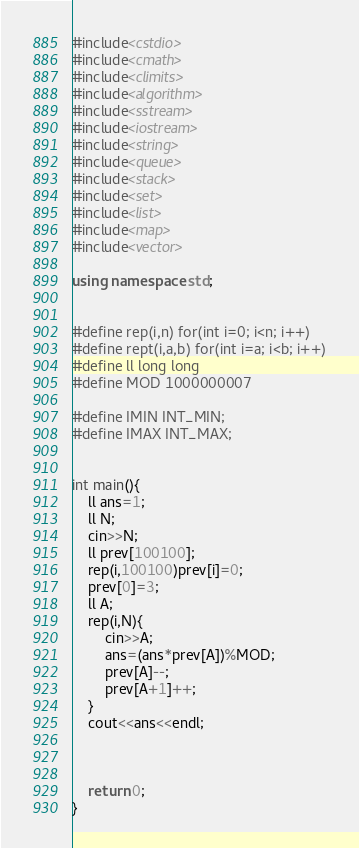Convert code to text. <code><loc_0><loc_0><loc_500><loc_500><_C++_>#include<cstdio>
#include<cmath>
#include<climits>
#include<algorithm>
#include<sstream>
#include<iostream>
#include<string>
#include<queue>
#include<stack>
#include<set>
#include<list>
#include<map>
#include<vector>

using namespace std;


#define rep(i,n) for(int i=0; i<n; i++)
#define rept(i,a,b) for(int i=a; i<b; i++)
#define ll long long
#define MOD 1000000007

#define IMIN INT_MIN;
#define IMAX INT_MAX;


int main(){
    ll ans=1;
    ll N;
    cin>>N;
    ll prev[100100];
    rep(i,100100)prev[i]=0;
    prev[0]=3;
    ll A;
    rep(i,N){
        cin>>A;
        ans=(ans*prev[A])%MOD;
        prev[A]--;
        prev[A+1]++;
    }
    cout<<ans<<endl;



	return 0;
}

</code> 